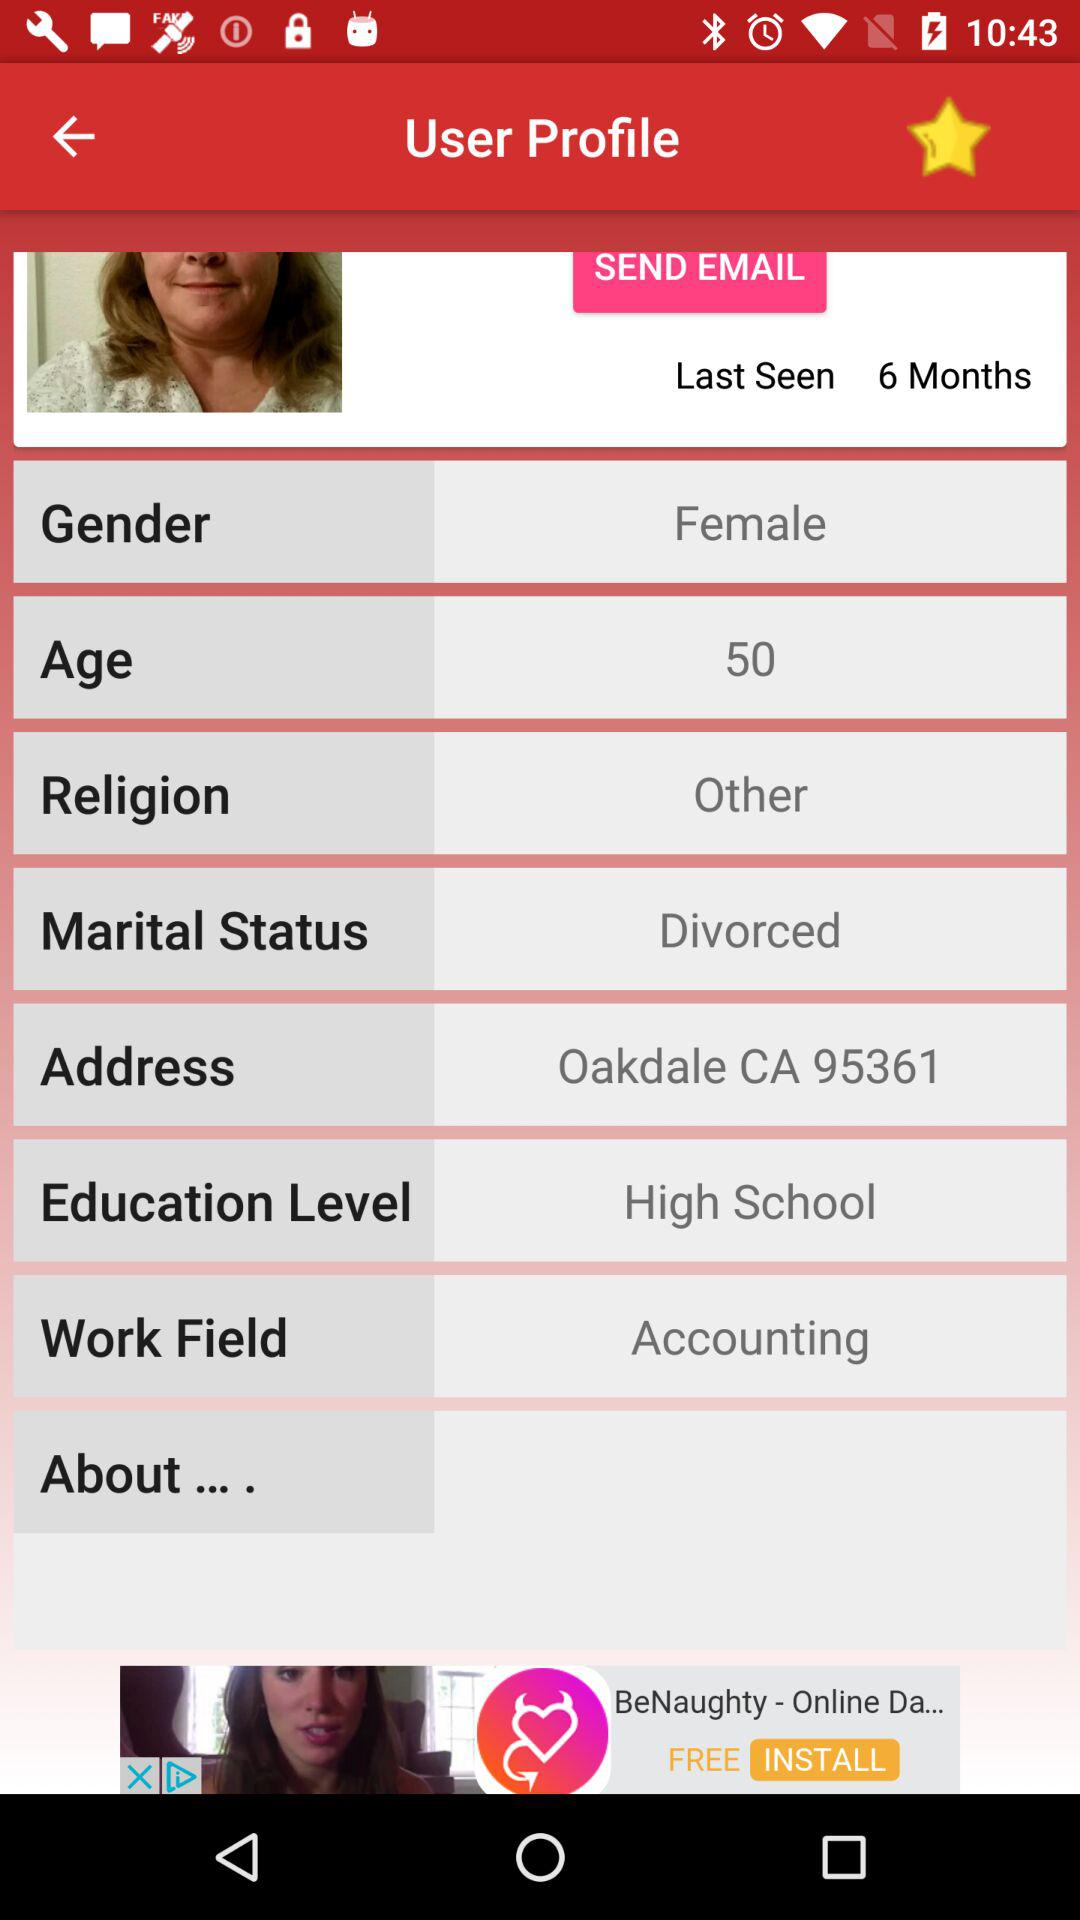What is the address of the user? The address of the user is Oakdale CA 95361. 